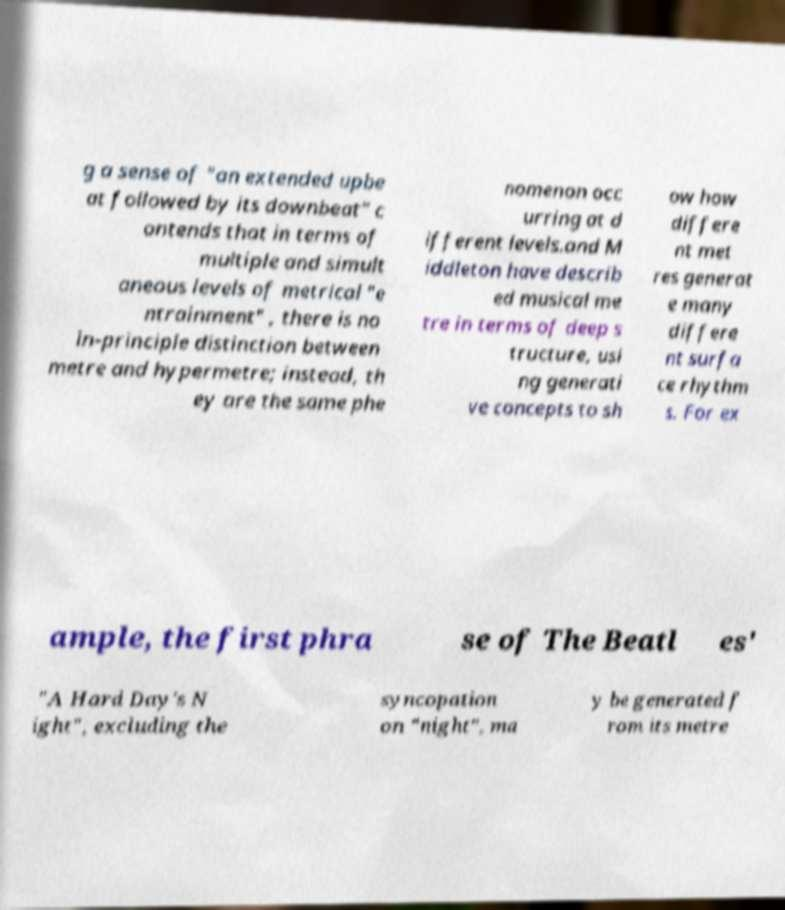Can you read and provide the text displayed in the image?This photo seems to have some interesting text. Can you extract and type it out for me? g a sense of "an extended upbe at followed by its downbeat" c ontends that in terms of multiple and simult aneous levels of metrical "e ntrainment" , there is no in-principle distinction between metre and hypermetre; instead, th ey are the same phe nomenon occ urring at d ifferent levels.and M iddleton have describ ed musical me tre in terms of deep s tructure, usi ng generati ve concepts to sh ow how differe nt met res generat e many differe nt surfa ce rhythm s. For ex ample, the first phra se of The Beatl es' "A Hard Day's N ight", excluding the syncopation on "night", ma y be generated f rom its metre 